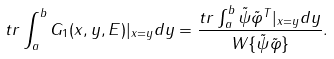<formula> <loc_0><loc_0><loc_500><loc_500>t r \int ^ { b } _ { a } G _ { 1 } ( x , y , E ) | _ { x = y } d y = \frac { t r \int ^ { b } _ { a } \tilde { \psi } \tilde { \varphi } ^ { T } | _ { x = y } d y } { W \{ \tilde { \psi } \tilde { \varphi } \} } .</formula> 